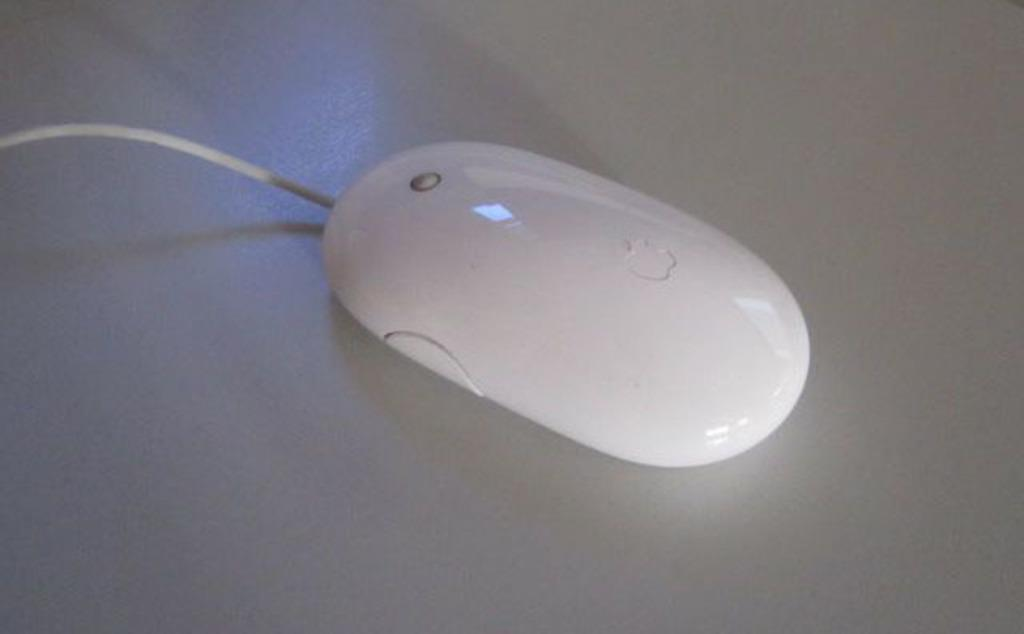What type of animal is present in the image? There is a mouse in the image. Can you describe the color of the mouse? The mouse is white in color. How many houses are visible in the image? There are no houses present in the image; it features a white mouse. What type of distribution system is depicted in the image? There is no distribution system present in the image. 